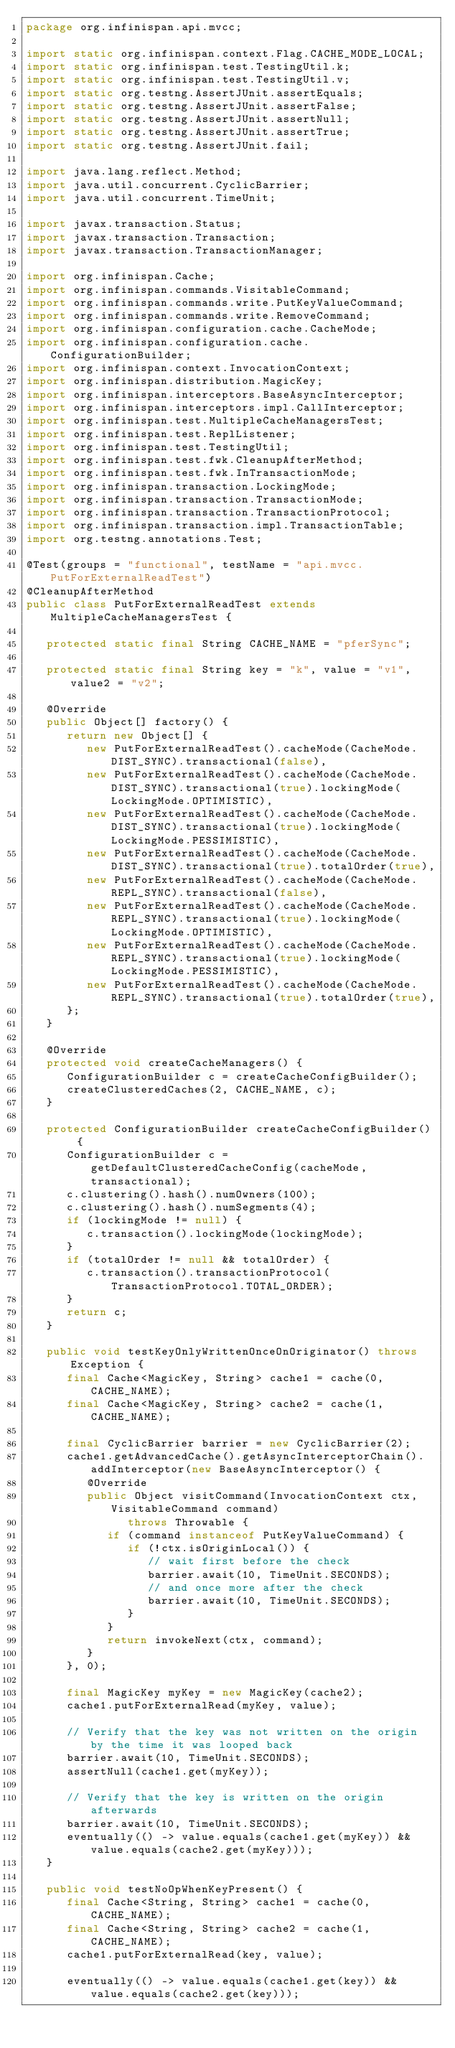Convert code to text. <code><loc_0><loc_0><loc_500><loc_500><_Java_>package org.infinispan.api.mvcc;

import static org.infinispan.context.Flag.CACHE_MODE_LOCAL;
import static org.infinispan.test.TestingUtil.k;
import static org.infinispan.test.TestingUtil.v;
import static org.testng.AssertJUnit.assertEquals;
import static org.testng.AssertJUnit.assertFalse;
import static org.testng.AssertJUnit.assertNull;
import static org.testng.AssertJUnit.assertTrue;
import static org.testng.AssertJUnit.fail;

import java.lang.reflect.Method;
import java.util.concurrent.CyclicBarrier;
import java.util.concurrent.TimeUnit;

import javax.transaction.Status;
import javax.transaction.Transaction;
import javax.transaction.TransactionManager;

import org.infinispan.Cache;
import org.infinispan.commands.VisitableCommand;
import org.infinispan.commands.write.PutKeyValueCommand;
import org.infinispan.commands.write.RemoveCommand;
import org.infinispan.configuration.cache.CacheMode;
import org.infinispan.configuration.cache.ConfigurationBuilder;
import org.infinispan.context.InvocationContext;
import org.infinispan.distribution.MagicKey;
import org.infinispan.interceptors.BaseAsyncInterceptor;
import org.infinispan.interceptors.impl.CallInterceptor;
import org.infinispan.test.MultipleCacheManagersTest;
import org.infinispan.test.ReplListener;
import org.infinispan.test.TestingUtil;
import org.infinispan.test.fwk.CleanupAfterMethod;
import org.infinispan.test.fwk.InTransactionMode;
import org.infinispan.transaction.LockingMode;
import org.infinispan.transaction.TransactionMode;
import org.infinispan.transaction.TransactionProtocol;
import org.infinispan.transaction.impl.TransactionTable;
import org.testng.annotations.Test;

@Test(groups = "functional", testName = "api.mvcc.PutForExternalReadTest")
@CleanupAfterMethod
public class PutForExternalReadTest extends MultipleCacheManagersTest {

   protected static final String CACHE_NAME = "pferSync";

   protected static final String key = "k", value = "v1", value2 = "v2";

   @Override
   public Object[] factory() {
      return new Object[] {
         new PutForExternalReadTest().cacheMode(CacheMode.DIST_SYNC).transactional(false),
         new PutForExternalReadTest().cacheMode(CacheMode.DIST_SYNC).transactional(true).lockingMode(LockingMode.OPTIMISTIC),
         new PutForExternalReadTest().cacheMode(CacheMode.DIST_SYNC).transactional(true).lockingMode(LockingMode.PESSIMISTIC),
         new PutForExternalReadTest().cacheMode(CacheMode.DIST_SYNC).transactional(true).totalOrder(true),
         new PutForExternalReadTest().cacheMode(CacheMode.REPL_SYNC).transactional(false),
         new PutForExternalReadTest().cacheMode(CacheMode.REPL_SYNC).transactional(true).lockingMode(LockingMode.OPTIMISTIC),
         new PutForExternalReadTest().cacheMode(CacheMode.REPL_SYNC).transactional(true).lockingMode(LockingMode.PESSIMISTIC),
         new PutForExternalReadTest().cacheMode(CacheMode.REPL_SYNC).transactional(true).totalOrder(true),
      };
   }

   @Override
   protected void createCacheManagers() {
      ConfigurationBuilder c = createCacheConfigBuilder();
      createClusteredCaches(2, CACHE_NAME, c);
   }

   protected ConfigurationBuilder createCacheConfigBuilder() {
      ConfigurationBuilder c = getDefaultClusteredCacheConfig(cacheMode, transactional);
      c.clustering().hash().numOwners(100);
      c.clustering().hash().numSegments(4);
      if (lockingMode != null) {
         c.transaction().lockingMode(lockingMode);
      }
      if (totalOrder != null && totalOrder) {
         c.transaction().transactionProtocol(TransactionProtocol.TOTAL_ORDER);
      }
      return c;
   }

   public void testKeyOnlyWrittenOnceOnOriginator() throws Exception {
      final Cache<MagicKey, String> cache1 = cache(0, CACHE_NAME);
      final Cache<MagicKey, String> cache2 = cache(1, CACHE_NAME);

      final CyclicBarrier barrier = new CyclicBarrier(2);
      cache1.getAdvancedCache().getAsyncInterceptorChain().addInterceptor(new BaseAsyncInterceptor() {
         @Override
         public Object visitCommand(InvocationContext ctx, VisitableCommand command)
               throws Throwable {
            if (command instanceof PutKeyValueCommand) {
               if (!ctx.isOriginLocal()) {
                  // wait first before the check
                  barrier.await(10, TimeUnit.SECONDS);
                  // and once more after the check
                  barrier.await(10, TimeUnit.SECONDS);
               }
            }
            return invokeNext(ctx, command);
         }
      }, 0);

      final MagicKey myKey = new MagicKey(cache2);
      cache1.putForExternalRead(myKey, value);

      // Verify that the key was not written on the origin by the time it was looped back
      barrier.await(10, TimeUnit.SECONDS);
      assertNull(cache1.get(myKey));

      // Verify that the key is written on the origin afterwards
      barrier.await(10, TimeUnit.SECONDS);
      eventually(() -> value.equals(cache1.get(myKey)) && value.equals(cache2.get(myKey)));
   }

   public void testNoOpWhenKeyPresent() {
      final Cache<String, String> cache1 = cache(0, CACHE_NAME);
      final Cache<String, String> cache2 = cache(1, CACHE_NAME);
      cache1.putForExternalRead(key, value);

      eventually(() -> value.equals(cache1.get(key)) && value.equals(cache2.get(key)));
</code> 